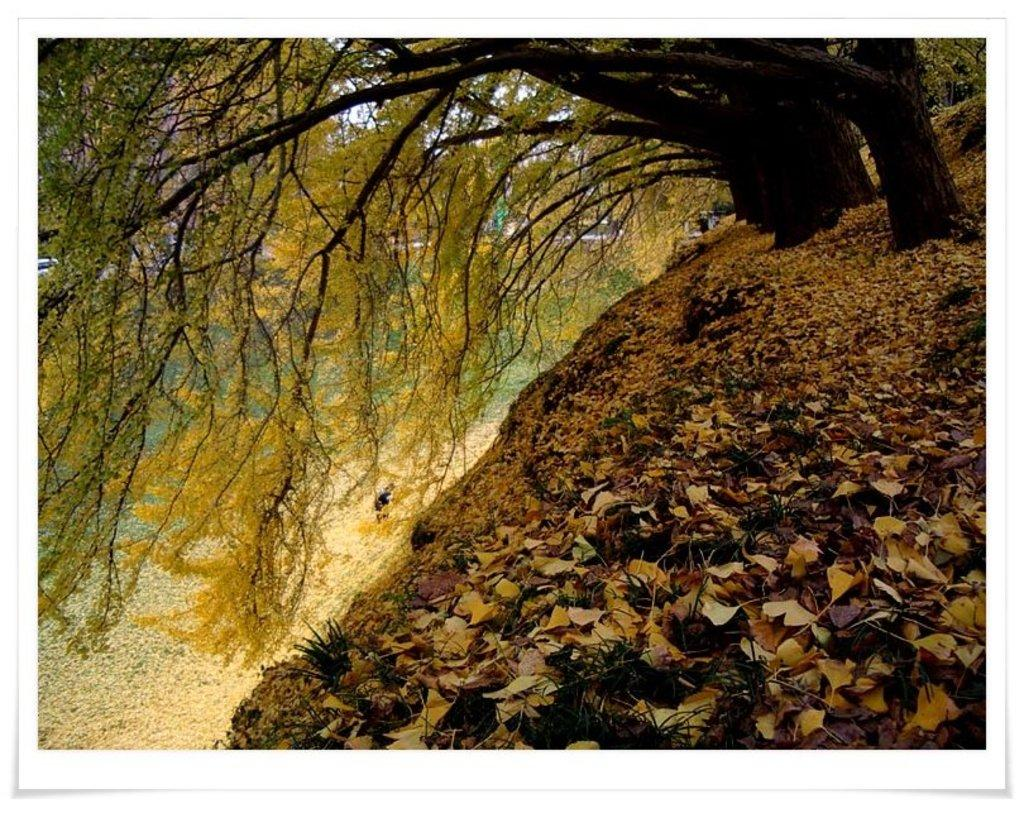What is the main feature of the landscape in the image? There are trees on a hill in the image. Can you describe any specific details about the trees or hill? The provided facts do not mention any specific details about the trees or hill. What can be seen in the bottom right of the image? There are dry leaves in the bottom right of the image. What type of clock is hanging from the tree in the image? There is no clock present in the image; it only features trees on a hill and dry leaves in the bottom right. What offer is being made by the pig in the image? There is no pig present in the image, so no offer can be made. 